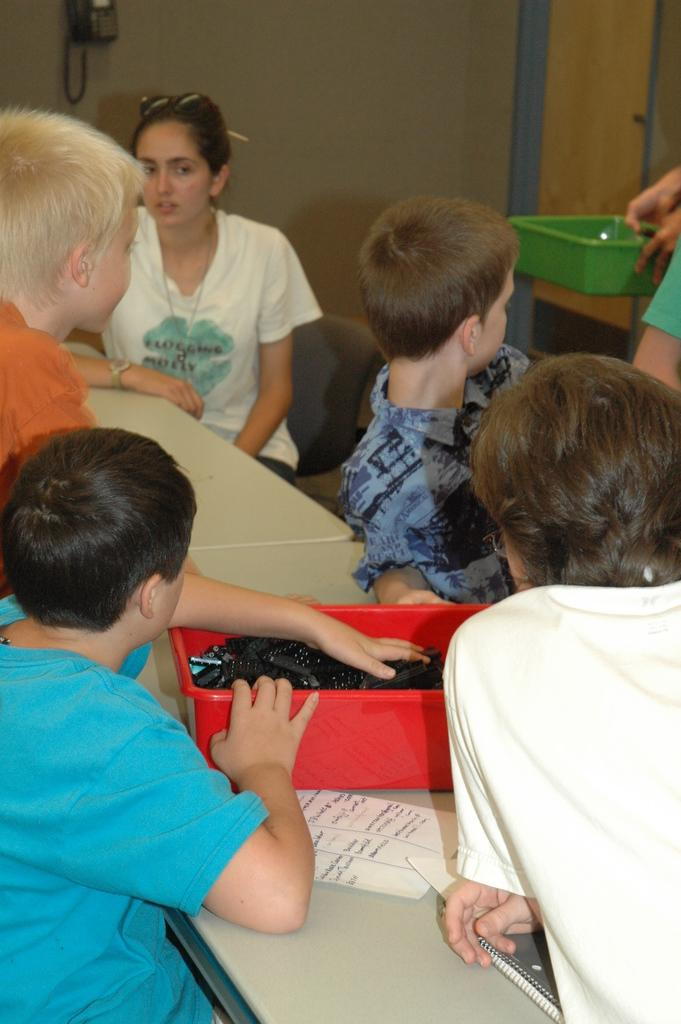What is the main subject of the image? The main subject of the image is a group of children. What are the children doing in the image? The children are sitting on chairs. What is in front of the children? There is a table in front of the children. Who else is present in the image? There is a woman in the image. What is the woman doing in the image? The woman is sitting on a chair. How is the woman positioned in relation to the children? The woman is at the top, presumably in relation to the children. What type of clouds can be seen in the image? There are no clouds present in the image. What riddle is the woman telling the children in the image? There is no indication in the image that the woman is telling a riddle to the children. 